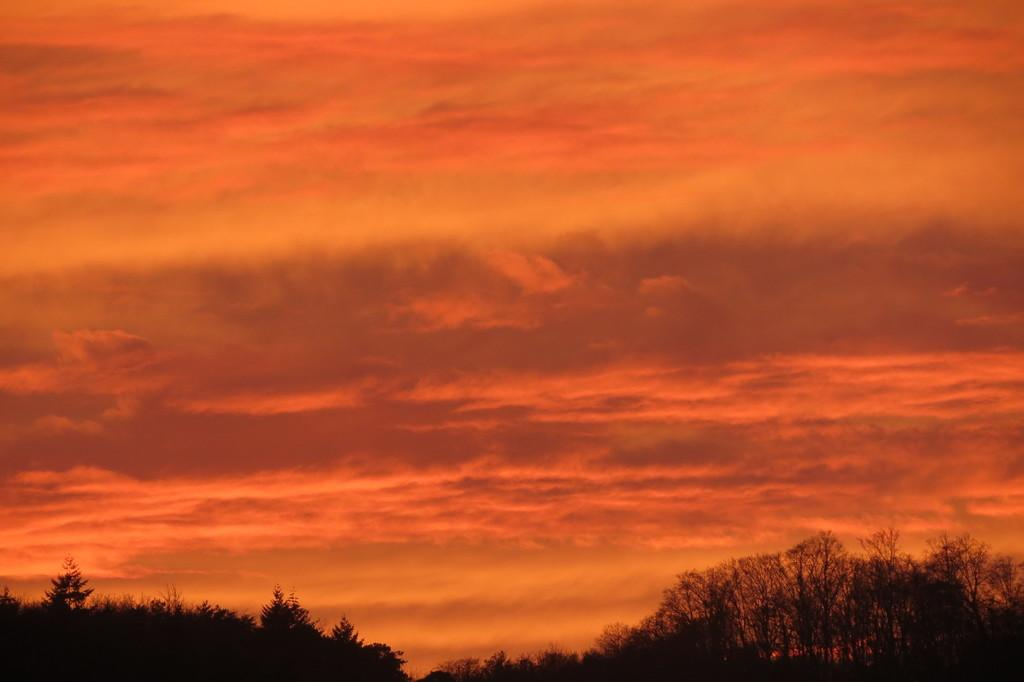What type of vegetation can be seen in the image? There are trees in the image. What is visible in the background of the image? There is a sky visible in the background of the image. What type of honey can be seen dripping from the trees in the image? There is no honey present in the image; it features trees and a sky. What kind of marble is visible on the ground in the image? There is no marble present in the image; it only shows trees and a sky. 